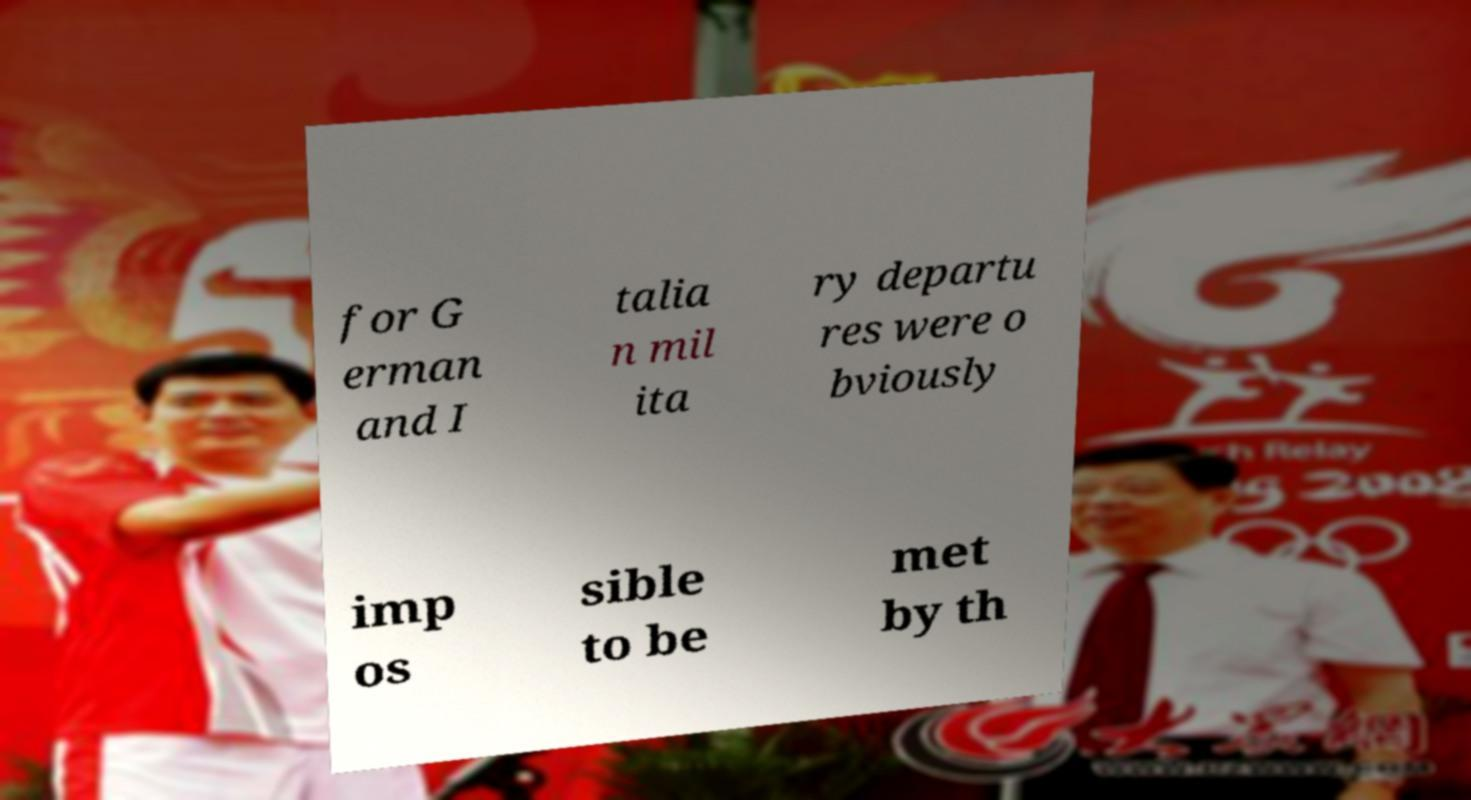I need the written content from this picture converted into text. Can you do that? for G erman and I talia n mil ita ry departu res were o bviously imp os sible to be met by th 